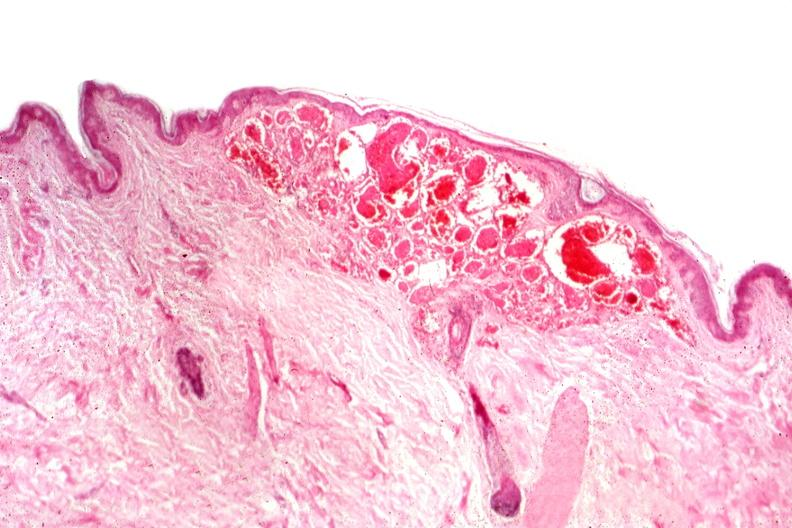s hemangioma present?
Answer the question using a single word or phrase. Yes 